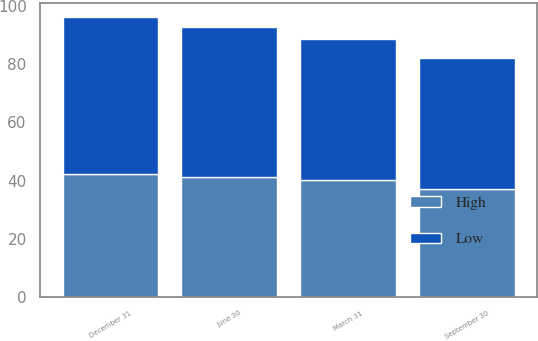<chart> <loc_0><loc_0><loc_500><loc_500><stacked_bar_chart><ecel><fcel>March 31<fcel>June 30<fcel>September 30<fcel>December 31<nl><fcel>High<fcel>40.23<fcel>41.23<fcel>36.95<fcel>42.19<nl><fcel>Low<fcel>48.38<fcel>51.66<fcel>45.19<fcel>54.24<nl></chart> 